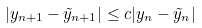Convert formula to latex. <formula><loc_0><loc_0><loc_500><loc_500>| y _ { n + 1 } - \tilde { y } _ { n + 1 } | \leq c | y _ { n } - \tilde { y } _ { n } |</formula> 